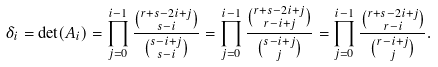<formula> <loc_0><loc_0><loc_500><loc_500>\delta _ { i } = \det ( A _ { i } ) = \prod _ { j = 0 } ^ { i - 1 } \frac { \binom { r + s - 2 i + j } { s - i } } { \binom { s - i + j } { s - i } } = \prod _ { j = 0 } ^ { i - 1 } \frac { \binom { r + s - 2 i + j } { r - i + j } } { \binom { s - i + j } { j } } = \prod _ { j = 0 } ^ { i - 1 } \frac { \binom { r + s - 2 i + j } { r - i } } { \binom { r - i + j } { j } } .</formula> 